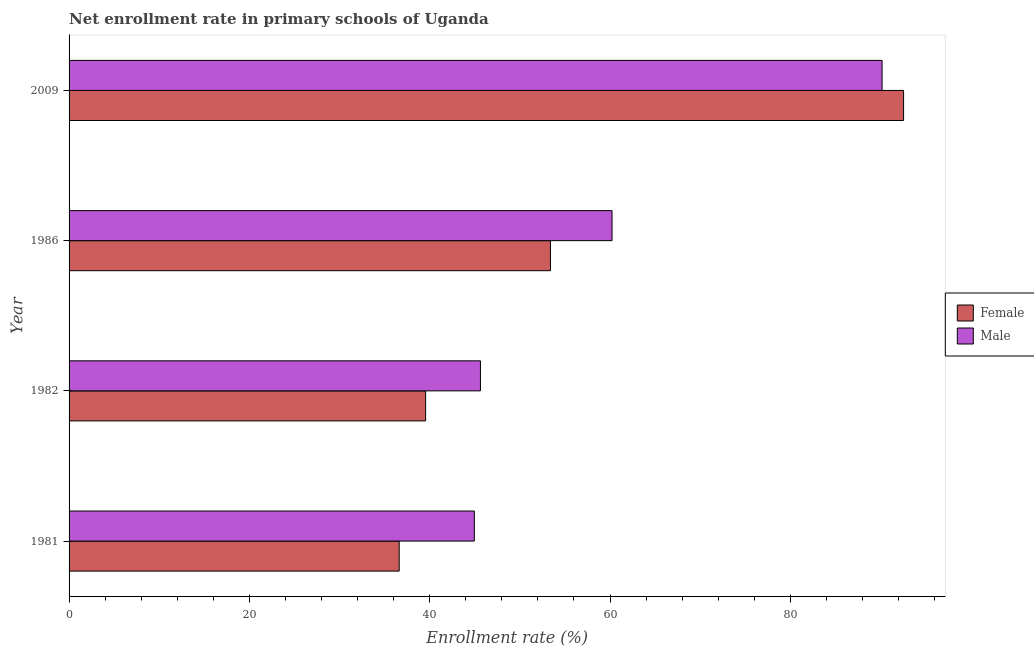In how many cases, is the number of bars for a given year not equal to the number of legend labels?
Your answer should be very brief. 0. What is the enrollment rate of male students in 1981?
Your response must be concise. 44.95. Across all years, what is the maximum enrollment rate of male students?
Keep it short and to the point. 90.18. Across all years, what is the minimum enrollment rate of male students?
Give a very brief answer. 44.95. In which year was the enrollment rate of male students maximum?
Your response must be concise. 2009. In which year was the enrollment rate of female students minimum?
Offer a terse response. 1981. What is the total enrollment rate of male students in the graph?
Your answer should be compact. 240.98. What is the difference between the enrollment rate of male students in 1981 and that in 1982?
Your answer should be very brief. -0.68. What is the difference between the enrollment rate of male students in 2009 and the enrollment rate of female students in 1986?
Your response must be concise. 36.78. What is the average enrollment rate of female students per year?
Offer a terse response. 55.53. In the year 1981, what is the difference between the enrollment rate of male students and enrollment rate of female students?
Keep it short and to the point. 8.34. In how many years, is the enrollment rate of female students greater than 12 %?
Keep it short and to the point. 4. What is the ratio of the enrollment rate of male students in 1982 to that in 1986?
Offer a terse response. 0.76. Is the difference between the enrollment rate of male students in 1981 and 1982 greater than the difference between the enrollment rate of female students in 1981 and 1982?
Your answer should be very brief. Yes. What is the difference between the highest and the second highest enrollment rate of female students?
Make the answer very short. 39.17. What is the difference between the highest and the lowest enrollment rate of female students?
Offer a terse response. 55.95. In how many years, is the enrollment rate of male students greater than the average enrollment rate of male students taken over all years?
Offer a very short reply. 1. Is the sum of the enrollment rate of female students in 1982 and 1986 greater than the maximum enrollment rate of male students across all years?
Provide a short and direct response. Yes. What does the 1st bar from the top in 1982 represents?
Offer a very short reply. Male. What does the 1st bar from the bottom in 1986 represents?
Ensure brevity in your answer.  Female. How many bars are there?
Give a very brief answer. 8. Does the graph contain any zero values?
Offer a very short reply. No. Does the graph contain grids?
Offer a terse response. No. How many legend labels are there?
Offer a terse response. 2. What is the title of the graph?
Your response must be concise. Net enrollment rate in primary schools of Uganda. What is the label or title of the X-axis?
Offer a terse response. Enrollment rate (%). What is the Enrollment rate (%) of Female in 1981?
Your response must be concise. 36.62. What is the Enrollment rate (%) of Male in 1981?
Your answer should be compact. 44.95. What is the Enrollment rate (%) of Female in 1982?
Your answer should be very brief. 39.55. What is the Enrollment rate (%) in Male in 1982?
Your answer should be very brief. 45.63. What is the Enrollment rate (%) of Female in 1986?
Your answer should be compact. 53.39. What is the Enrollment rate (%) of Male in 1986?
Ensure brevity in your answer.  60.22. What is the Enrollment rate (%) of Female in 2009?
Ensure brevity in your answer.  92.56. What is the Enrollment rate (%) of Male in 2009?
Keep it short and to the point. 90.18. Across all years, what is the maximum Enrollment rate (%) of Female?
Provide a short and direct response. 92.56. Across all years, what is the maximum Enrollment rate (%) of Male?
Your answer should be compact. 90.18. Across all years, what is the minimum Enrollment rate (%) of Female?
Provide a short and direct response. 36.62. Across all years, what is the minimum Enrollment rate (%) of Male?
Your response must be concise. 44.95. What is the total Enrollment rate (%) in Female in the graph?
Provide a succinct answer. 222.12. What is the total Enrollment rate (%) in Male in the graph?
Offer a very short reply. 240.98. What is the difference between the Enrollment rate (%) of Female in 1981 and that in 1982?
Keep it short and to the point. -2.93. What is the difference between the Enrollment rate (%) in Male in 1981 and that in 1982?
Keep it short and to the point. -0.68. What is the difference between the Enrollment rate (%) in Female in 1981 and that in 1986?
Offer a very short reply. -16.78. What is the difference between the Enrollment rate (%) of Male in 1981 and that in 1986?
Your answer should be very brief. -15.27. What is the difference between the Enrollment rate (%) of Female in 1981 and that in 2009?
Your answer should be very brief. -55.95. What is the difference between the Enrollment rate (%) in Male in 1981 and that in 2009?
Your answer should be very brief. -45.23. What is the difference between the Enrollment rate (%) of Female in 1982 and that in 1986?
Provide a short and direct response. -13.85. What is the difference between the Enrollment rate (%) of Male in 1982 and that in 1986?
Give a very brief answer. -14.6. What is the difference between the Enrollment rate (%) of Female in 1982 and that in 2009?
Provide a short and direct response. -53.02. What is the difference between the Enrollment rate (%) in Male in 1982 and that in 2009?
Ensure brevity in your answer.  -44.55. What is the difference between the Enrollment rate (%) in Female in 1986 and that in 2009?
Your response must be concise. -39.17. What is the difference between the Enrollment rate (%) of Male in 1986 and that in 2009?
Your answer should be very brief. -29.95. What is the difference between the Enrollment rate (%) in Female in 1981 and the Enrollment rate (%) in Male in 1982?
Make the answer very short. -9.01. What is the difference between the Enrollment rate (%) in Female in 1981 and the Enrollment rate (%) in Male in 1986?
Offer a terse response. -23.61. What is the difference between the Enrollment rate (%) in Female in 1981 and the Enrollment rate (%) in Male in 2009?
Make the answer very short. -53.56. What is the difference between the Enrollment rate (%) in Female in 1982 and the Enrollment rate (%) in Male in 1986?
Your answer should be compact. -20.68. What is the difference between the Enrollment rate (%) of Female in 1982 and the Enrollment rate (%) of Male in 2009?
Ensure brevity in your answer.  -50.63. What is the difference between the Enrollment rate (%) of Female in 1986 and the Enrollment rate (%) of Male in 2009?
Make the answer very short. -36.78. What is the average Enrollment rate (%) in Female per year?
Make the answer very short. 55.53. What is the average Enrollment rate (%) in Male per year?
Offer a very short reply. 60.25. In the year 1981, what is the difference between the Enrollment rate (%) in Female and Enrollment rate (%) in Male?
Provide a succinct answer. -8.34. In the year 1982, what is the difference between the Enrollment rate (%) in Female and Enrollment rate (%) in Male?
Your response must be concise. -6.08. In the year 1986, what is the difference between the Enrollment rate (%) of Female and Enrollment rate (%) of Male?
Provide a short and direct response. -6.83. In the year 2009, what is the difference between the Enrollment rate (%) in Female and Enrollment rate (%) in Male?
Provide a succinct answer. 2.38. What is the ratio of the Enrollment rate (%) of Female in 1981 to that in 1982?
Give a very brief answer. 0.93. What is the ratio of the Enrollment rate (%) in Male in 1981 to that in 1982?
Offer a very short reply. 0.99. What is the ratio of the Enrollment rate (%) in Female in 1981 to that in 1986?
Provide a short and direct response. 0.69. What is the ratio of the Enrollment rate (%) of Male in 1981 to that in 1986?
Provide a short and direct response. 0.75. What is the ratio of the Enrollment rate (%) in Female in 1981 to that in 2009?
Provide a short and direct response. 0.4. What is the ratio of the Enrollment rate (%) in Male in 1981 to that in 2009?
Offer a very short reply. 0.5. What is the ratio of the Enrollment rate (%) in Female in 1982 to that in 1986?
Ensure brevity in your answer.  0.74. What is the ratio of the Enrollment rate (%) of Male in 1982 to that in 1986?
Your response must be concise. 0.76. What is the ratio of the Enrollment rate (%) of Female in 1982 to that in 2009?
Keep it short and to the point. 0.43. What is the ratio of the Enrollment rate (%) of Male in 1982 to that in 2009?
Offer a very short reply. 0.51. What is the ratio of the Enrollment rate (%) of Female in 1986 to that in 2009?
Provide a short and direct response. 0.58. What is the ratio of the Enrollment rate (%) in Male in 1986 to that in 2009?
Offer a very short reply. 0.67. What is the difference between the highest and the second highest Enrollment rate (%) in Female?
Ensure brevity in your answer.  39.17. What is the difference between the highest and the second highest Enrollment rate (%) of Male?
Your answer should be compact. 29.95. What is the difference between the highest and the lowest Enrollment rate (%) in Female?
Keep it short and to the point. 55.95. What is the difference between the highest and the lowest Enrollment rate (%) in Male?
Provide a succinct answer. 45.23. 